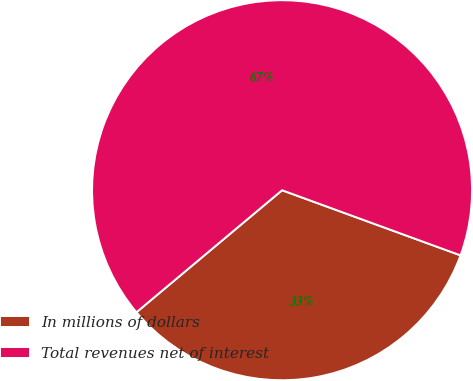<chart> <loc_0><loc_0><loc_500><loc_500><pie_chart><fcel>In millions of dollars<fcel>Total revenues net of interest<nl><fcel>33.33%<fcel>66.67%<nl></chart> 